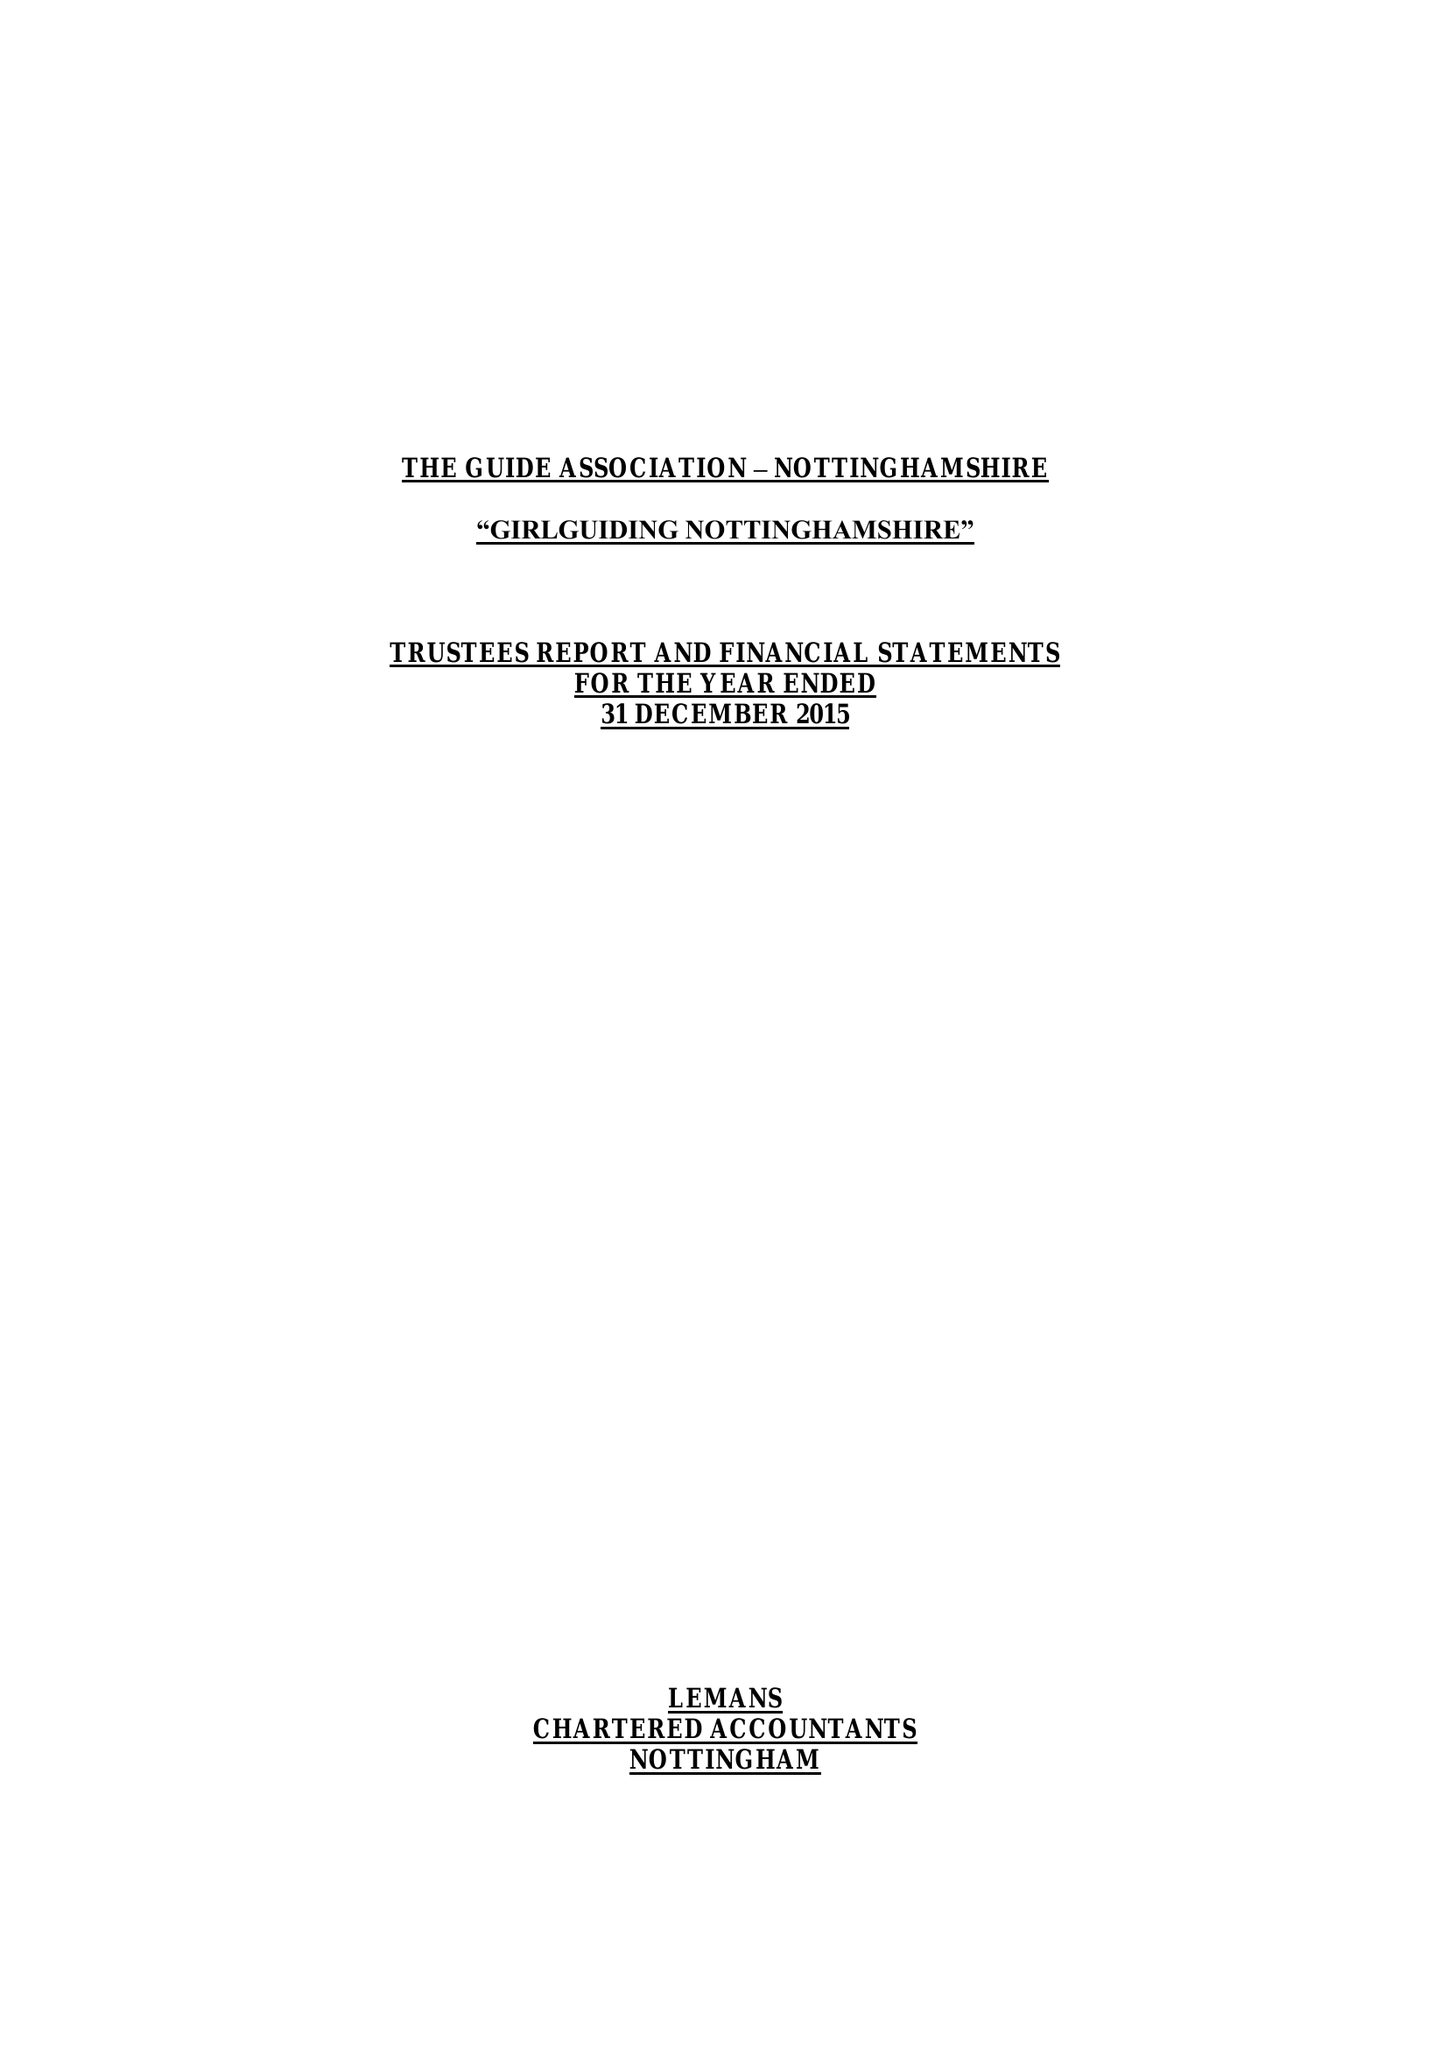What is the value for the income_annually_in_british_pounds?
Answer the question using a single word or phrase. 246334.00 